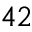Convert formula to latex. <formula><loc_0><loc_0><loc_500><loc_500>4 2</formula> 